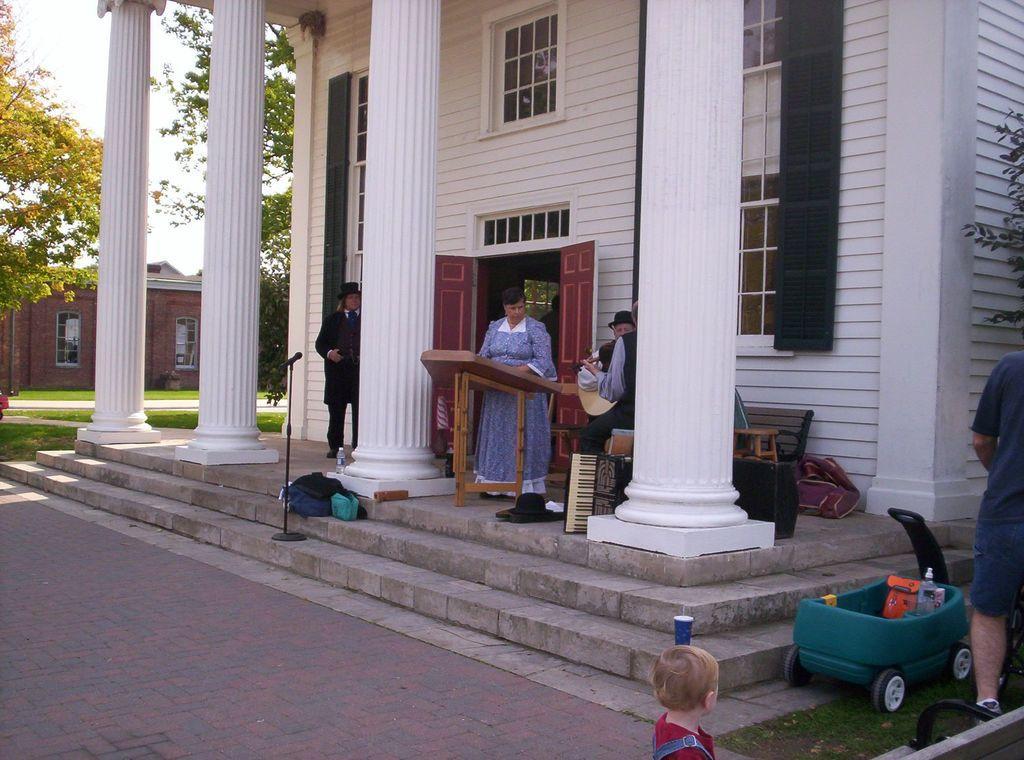Describe this image in one or two sentences. In this picture, we see the woman in blue dress is standing in front of the table. Beside her, we see two men standing and holding musical instruments. Behind them, we see a bench. Beside the women, we see pillars. Behind her, we see a building in white color. In front of them, we see a staircase and a microphone and a blue bag are placed on the staircase. On the right side, we see a vehicle in green color. We even see the boy in the red shirt is standing. In the background, there are trees and buildings. 